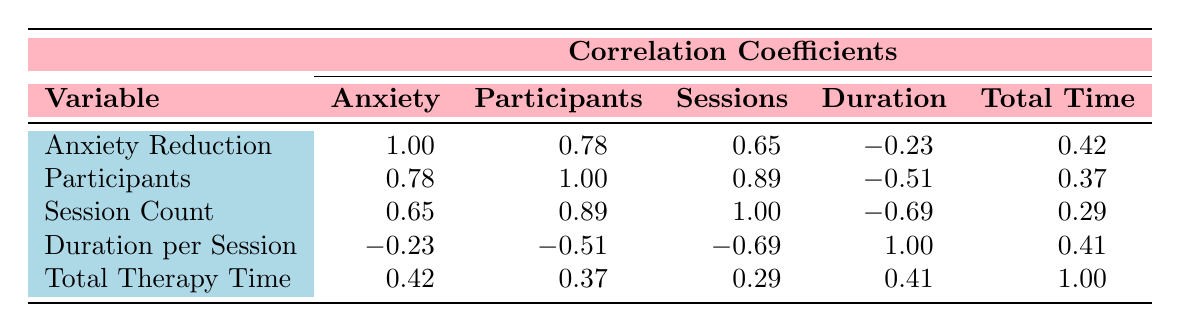What is the anxiety reduction score for Cognitive Behavioral Therapy? The table shows that the anxiety reduction score for Cognitive Behavioral Therapy (CBT) is 80.
Answer: 80 How many participants were involved in Art Therapy? According to the table, the number of participants involved in Art Therapy is 50.
Answer: 50 What is the total therapy time for Hypnosis? The total therapy time is not directly provided, but we can calculate it as (number of sessions * duration per session). For Hypnosis, that's 5 sessions * 60 minutes = 300 minutes.
Answer: 300 minutes Is the anxiety reduction score positively correlated with the number of participants? The correlation coefficient between anxiety reduction and participants is 0.78, indicating a positive correlation. Therefore, yes, they are positively correlated.
Answer: Yes What is the average anxiety reduction score across all therapies? To find the average, add all anxiety reduction scores: 75 (Art Therapy) + 67 (Hypnosis) + 70 (Mindfulness) + 80 (CBT) + 65 (Yoga) = 357, then divide by 5 therapies. So, 357/5 = 71.4.
Answer: 71.4 Which therapy has the highest anxiety reduction score, and what is that score? From the table, Cognitive Behavioral Therapy (CBT) has the highest anxiety reduction score of 80.
Answer: Cognitive Behavioral Therapy, 80 If we compare the number of sessions of Yoga and Mindfulness Meditation, which therapy has more sessions? Yoga has 6 sessions and Mindfulness Meditation has 10 sessions. Since 10 > 6, Mindfulness Meditation has more sessions.
Answer: Mindfulness Meditation What is the correlation between session count and anxiety reduction score? The table shows a correlation coefficient of 0.65 between session count and anxiety reduction score, indicating a positive correlation.
Answer: 0.65 